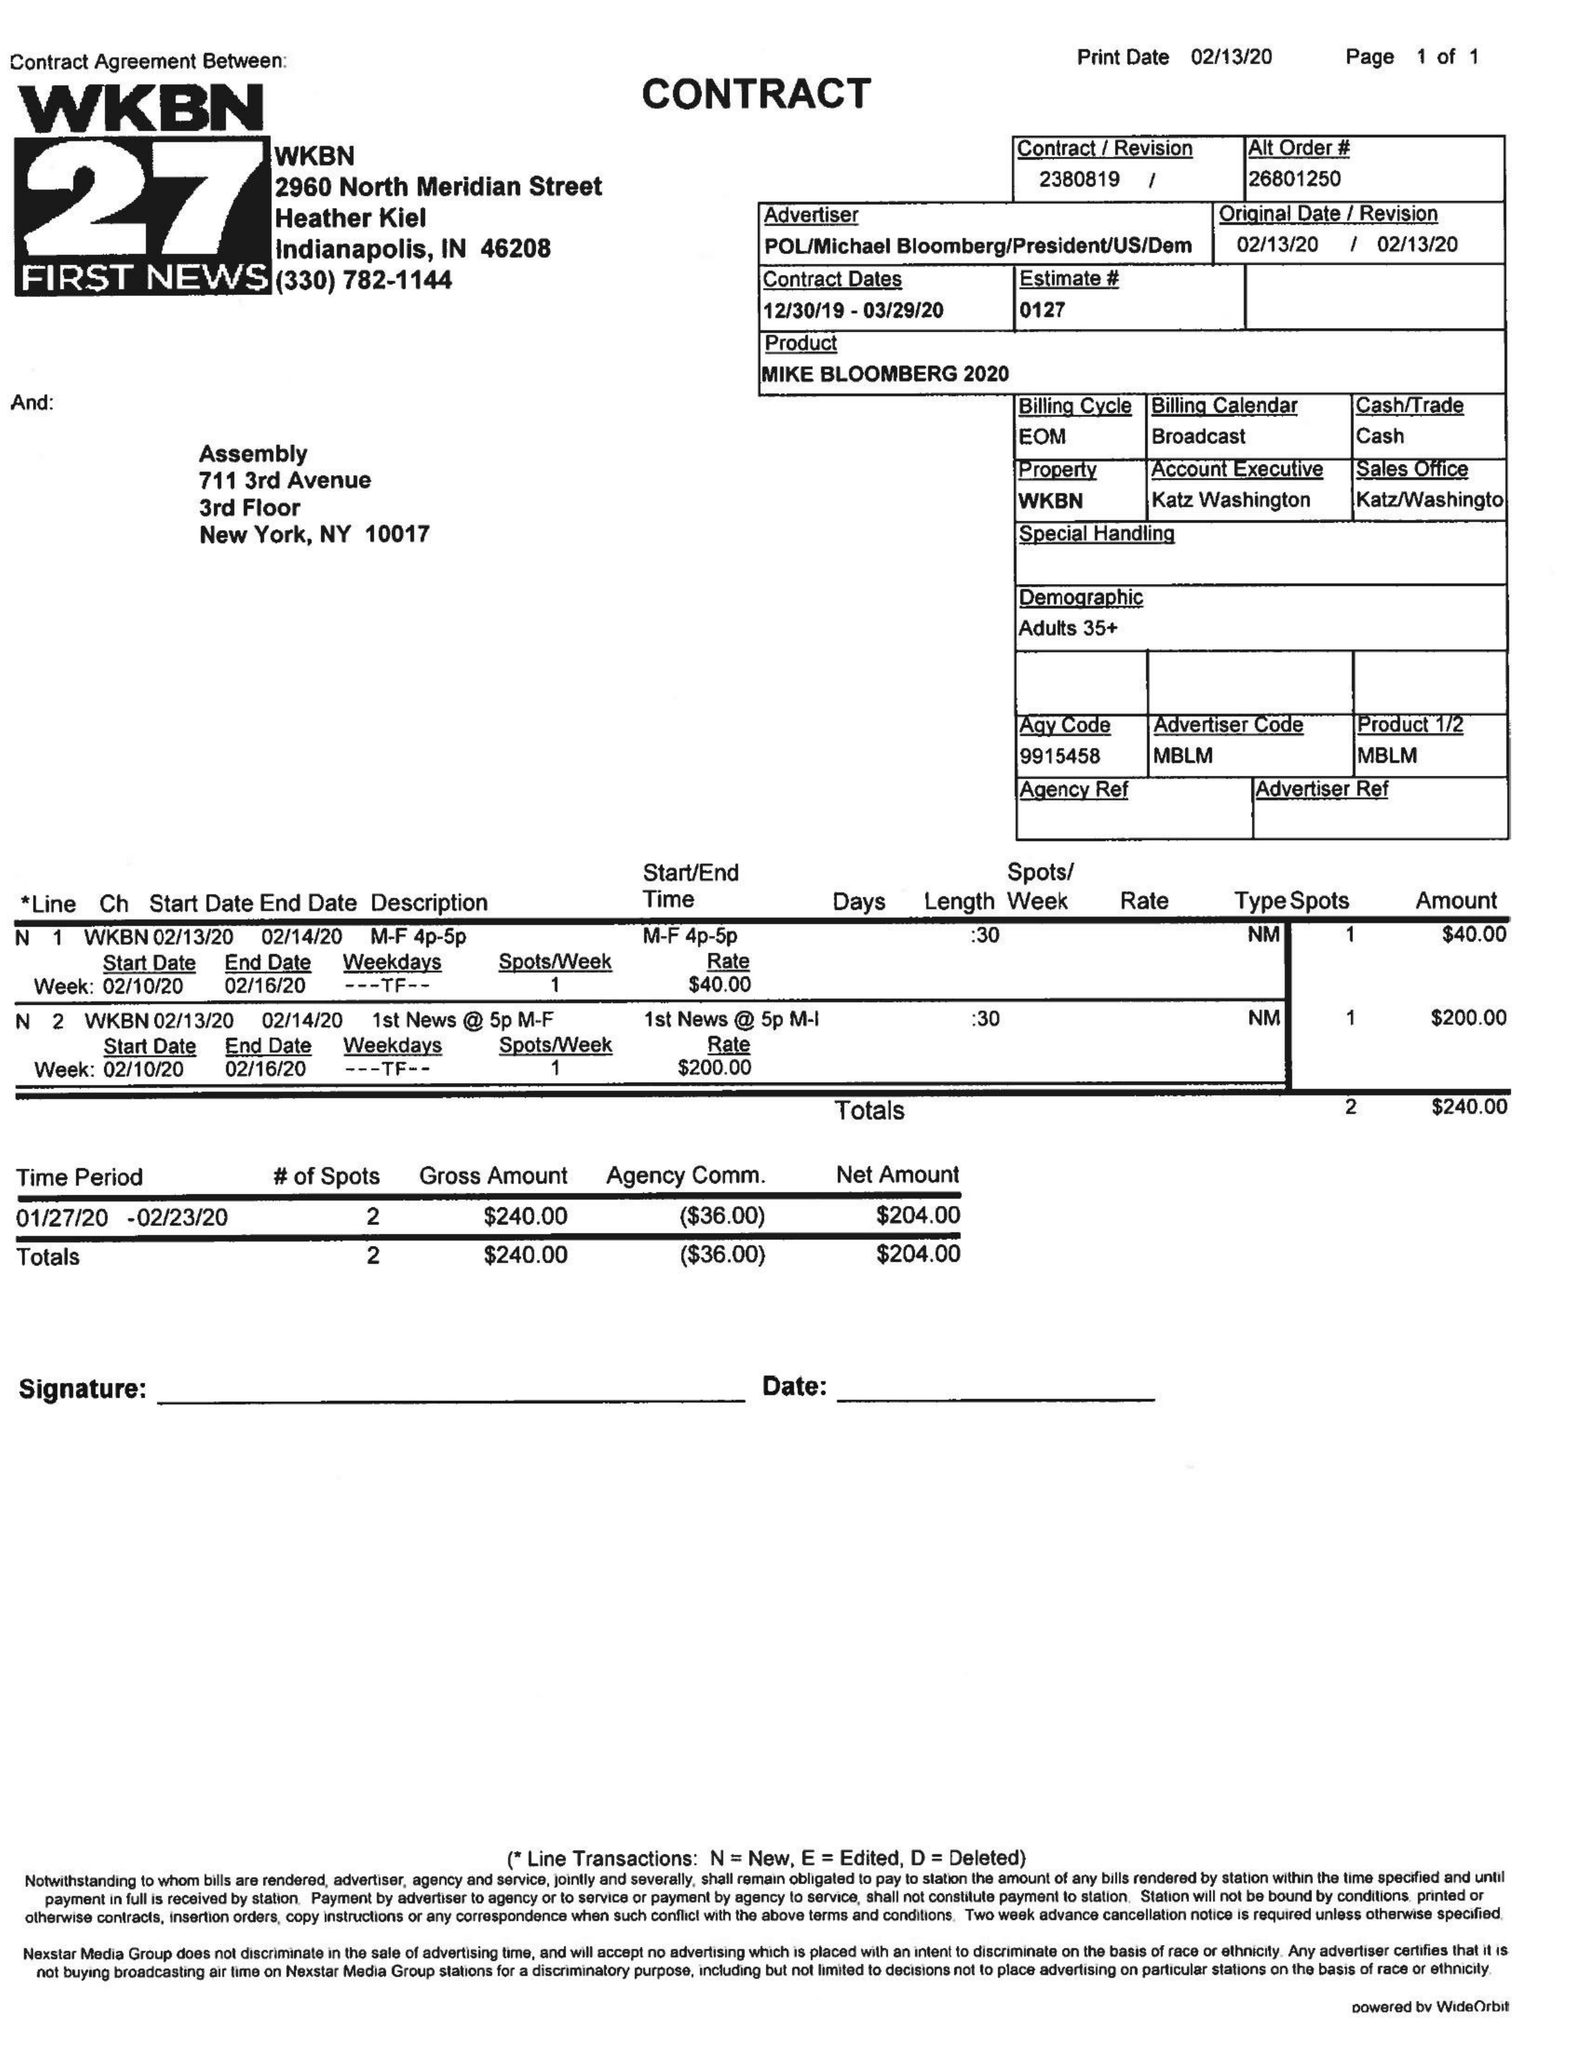What is the value for the gross_amount?
Answer the question using a single word or phrase. 240.00 